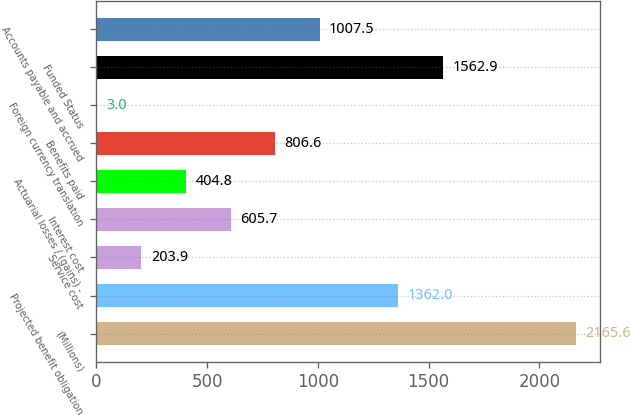Convert chart. <chart><loc_0><loc_0><loc_500><loc_500><bar_chart><fcel>(Millions)<fcel>Projected benefit obligation<fcel>Service cost<fcel>Interest cost<fcel>Actuarial losses / (gains) -<fcel>Benefits paid<fcel>Foreign currency translation<fcel>Funded Status<fcel>Accounts payable and accrued<nl><fcel>2165.6<fcel>1362<fcel>203.9<fcel>605.7<fcel>404.8<fcel>806.6<fcel>3<fcel>1562.9<fcel>1007.5<nl></chart> 